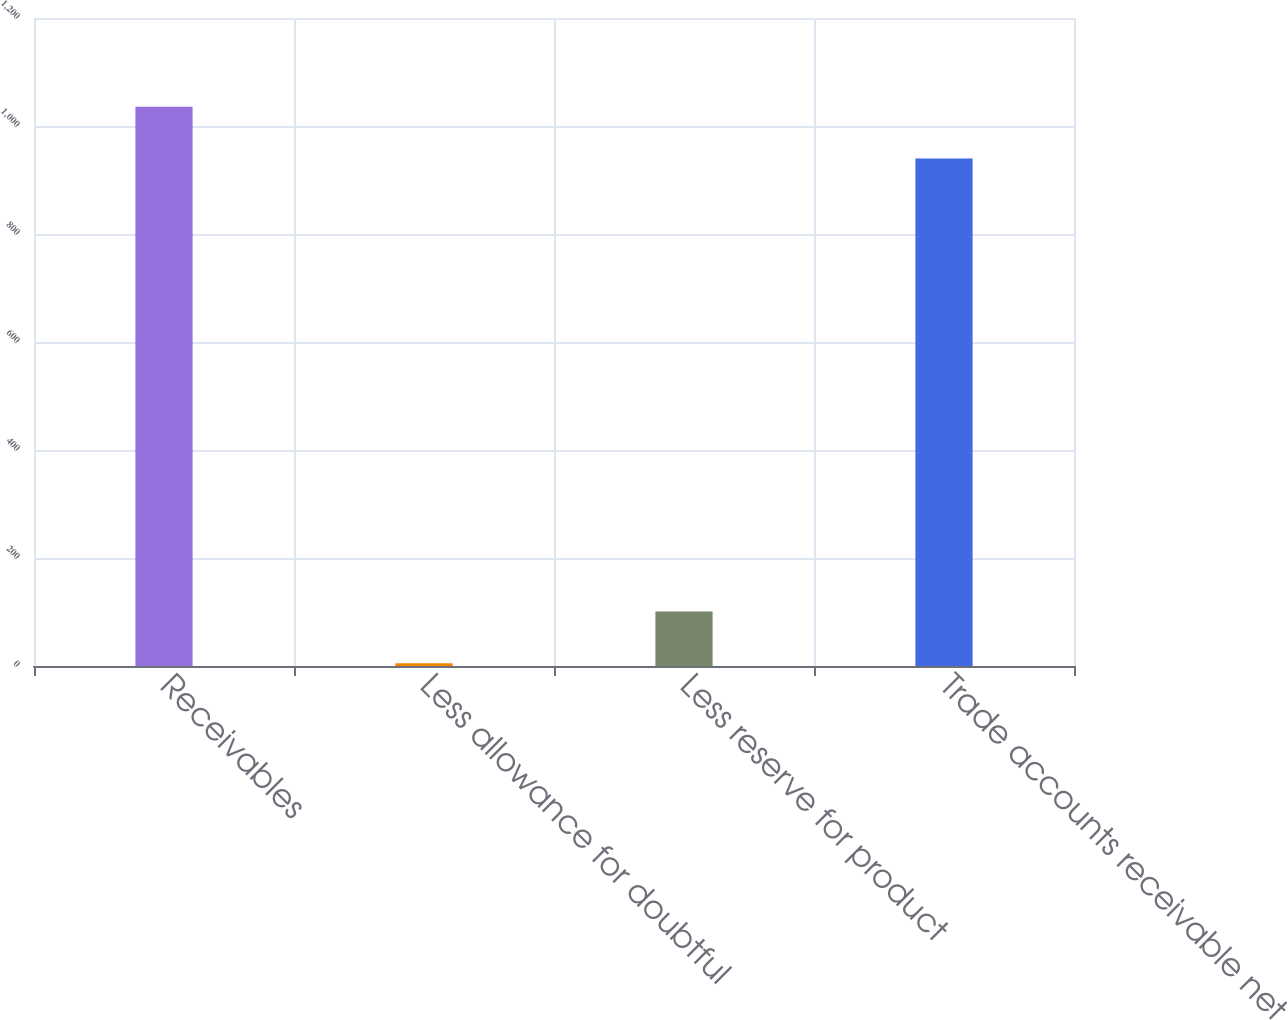<chart> <loc_0><loc_0><loc_500><loc_500><bar_chart><fcel>Receivables<fcel>Less allowance for doubtful<fcel>Less reserve for product<fcel>Trade accounts receivable net<nl><fcel>1035.7<fcel>5<fcel>100.7<fcel>940<nl></chart> 